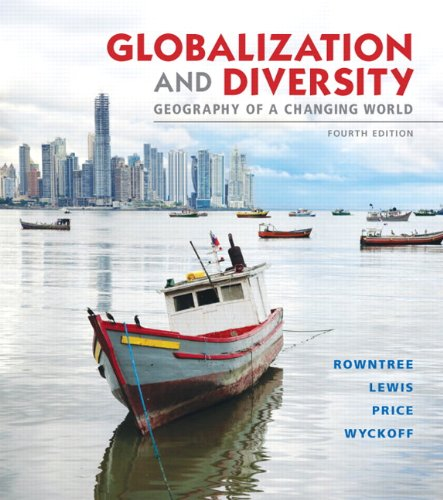What is the title of this book? The title of the book is 'Globalization and Diversity: Geography of a Changing World', and this is the fourth edition. 